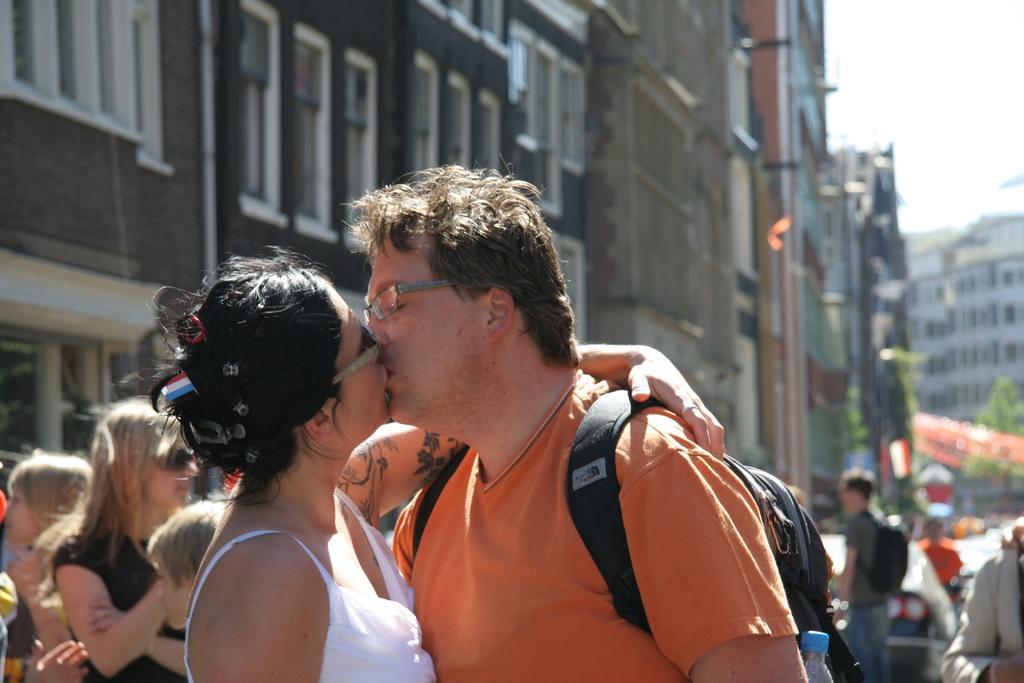Can you describe this image briefly? In the picture we can see a man and a woman are kissing on the road, man is wearing a orange T-shirt with a bag and woman is wearing a white dress and behind them we can see some people are standing and near to them we can see some buildings and windows to it and in the background also we can see some buildings, trees, car and a sky. 